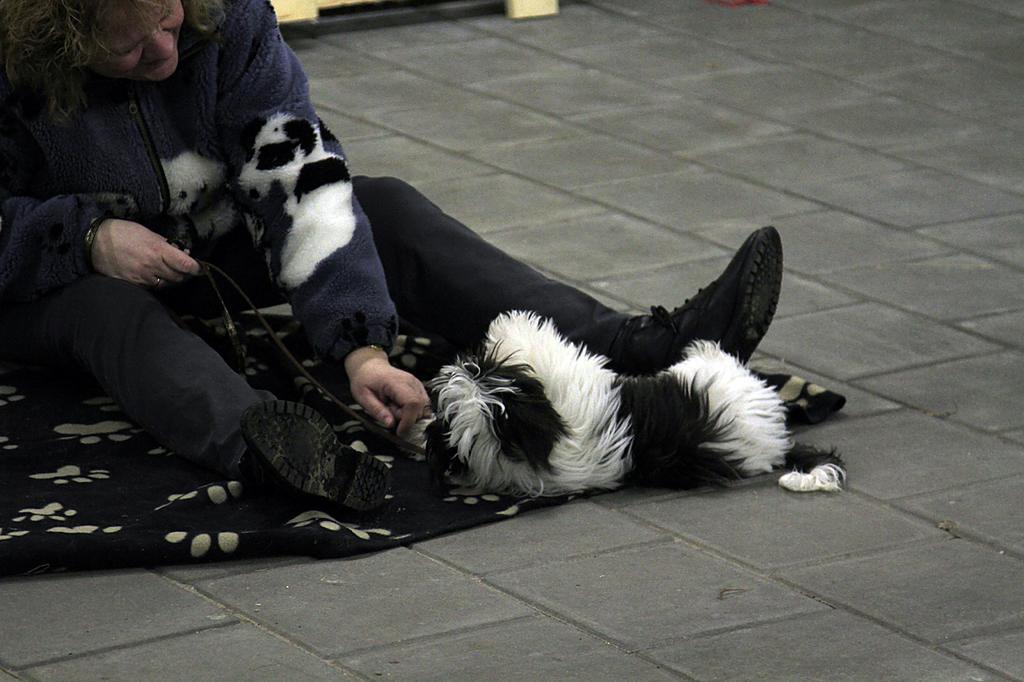What is the person in the image doing? The person is sitting in the image. What type of clothing is the person wearing? The person is wearing a jacket, shoes, and jeans. What is the animal lying on the floor in the image? The facts provided do not specify the type of animal. How does the chicken contribute to the person's digestion in the image? There is no chicken present in the image, so it cannot contribute to the person's digestion. 